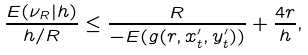<formula> <loc_0><loc_0><loc_500><loc_500>\frac { E ( \nu _ { R } | h ) } { h / R } \leq \frac { R } { - E ( g ( r , x ^ { \prime } _ { t } , y ^ { \prime } _ { t } ) ) } + \frac { 4 r } { h } ,</formula> 